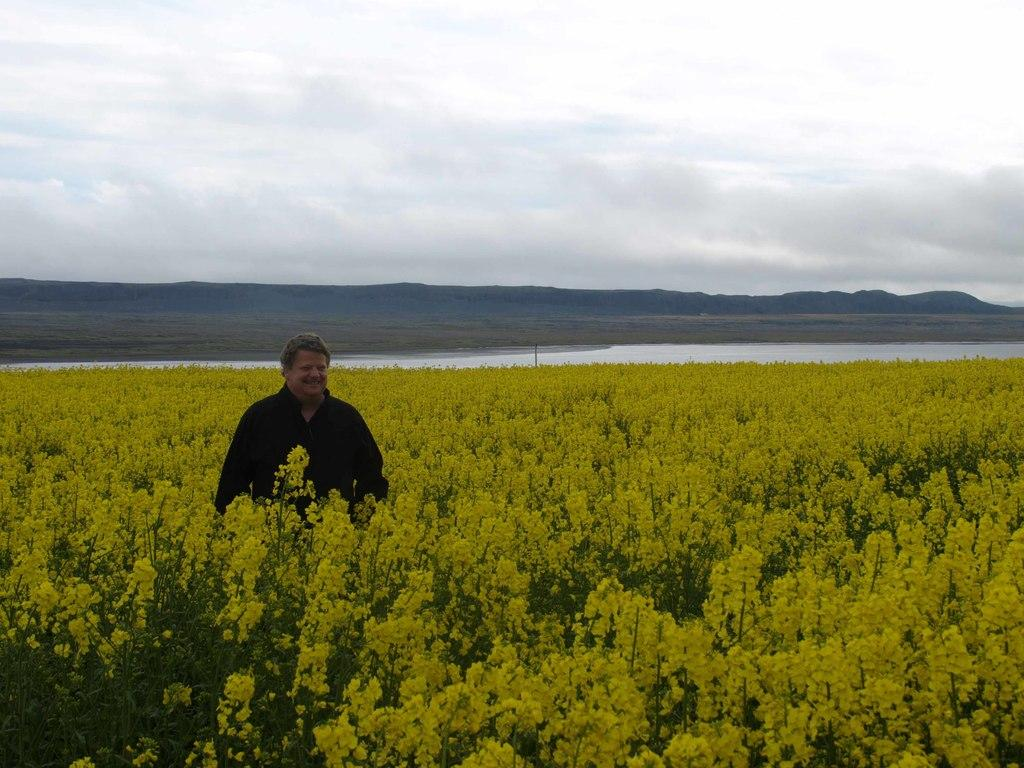What type of living organisms can be seen in the image? Plants and flowers are visible in the image. What is the man wearing in the image? There is a man wearing a black shirt in the image. What can be seen in the water in the image? The provided facts do not mention anything specific about the water, so we cannot determine what can be seen in it. What is visible at the top of the image? The sky is visible at the top of the image. What type of test is the man conducting in the image? There is no indication in the image that the man is conducting a test, so it cannot be determined from the picture. 